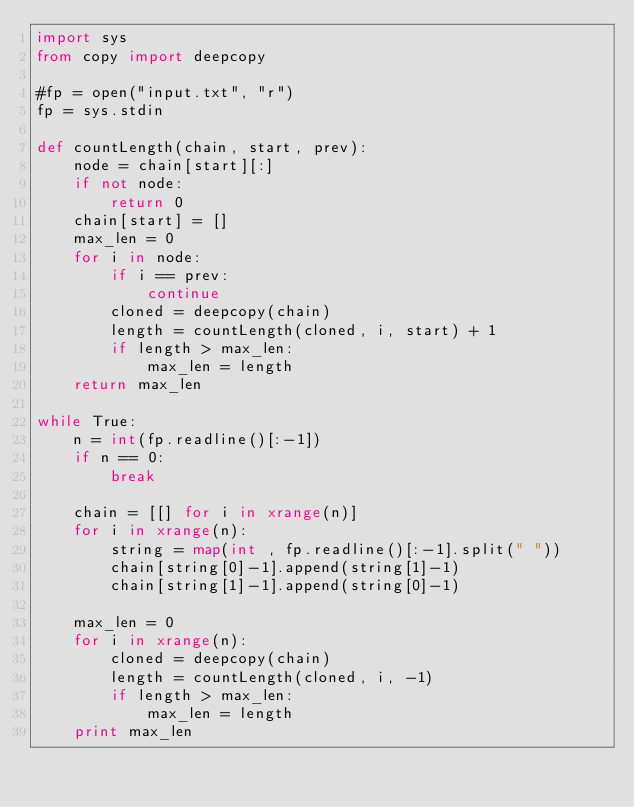Convert code to text. <code><loc_0><loc_0><loc_500><loc_500><_Python_>import sys
from copy import deepcopy

#fp = open("input.txt", "r")
fp = sys.stdin

def countLength(chain, start, prev):
    node = chain[start][:]
    if not node:
        return 0
    chain[start] = []
    max_len = 0
    for i in node:
        if i == prev:
            continue
        cloned = deepcopy(chain)
        length = countLength(cloned, i, start) + 1
        if length > max_len:
            max_len = length
    return max_len

while True:
    n = int(fp.readline()[:-1])
    if n == 0:
        break

    chain = [[] for i in xrange(n)]
    for i in xrange(n):
        string = map(int , fp.readline()[:-1].split(" "))
        chain[string[0]-1].append(string[1]-1)
        chain[string[1]-1].append(string[0]-1)

    max_len = 0
    for i in xrange(n):
        cloned = deepcopy(chain)
        length = countLength(cloned, i, -1)
        if length > max_len:
            max_len = length
    print max_len</code> 